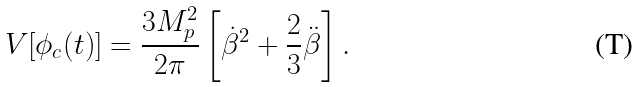Convert formula to latex. <formula><loc_0><loc_0><loc_500><loc_500>V [ \phi _ { c } ( t ) ] = \frac { 3 M ^ { 2 } _ { p } } { 2 \pi } \left [ \dot { \beta } ^ { 2 } + \frac { 2 } { 3 } \ddot { \beta } \right ] .</formula> 